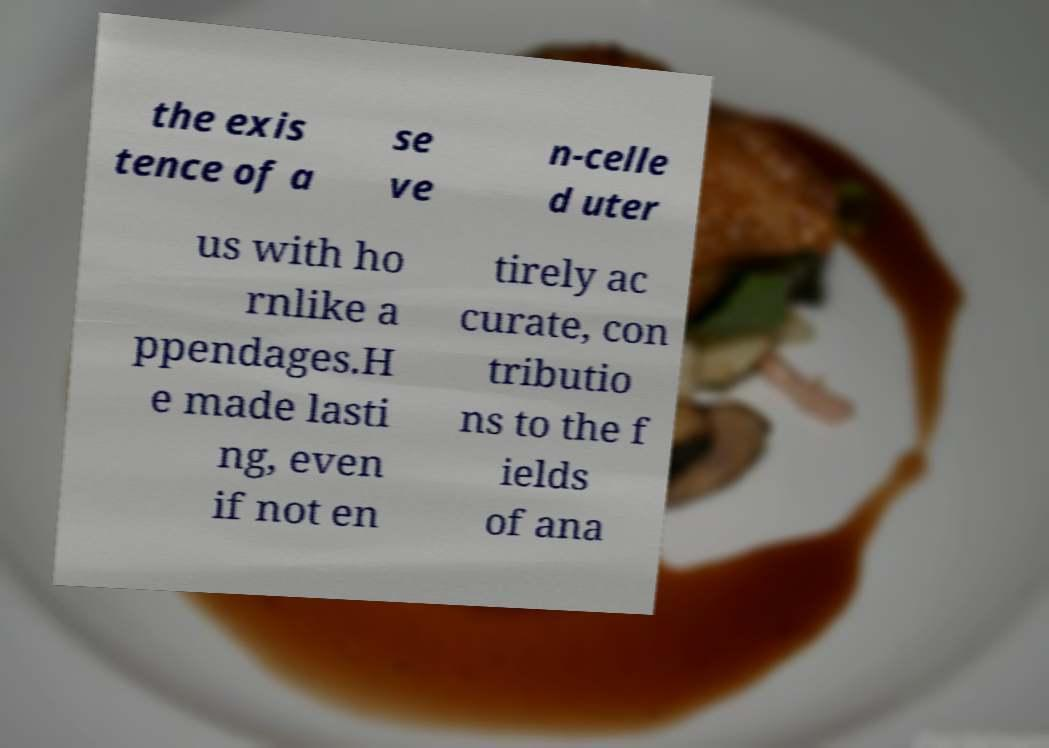Please identify and transcribe the text found in this image. the exis tence of a se ve n-celle d uter us with ho rnlike a ppendages.H e made lasti ng, even if not en tirely ac curate, con tributio ns to the f ields of ana 